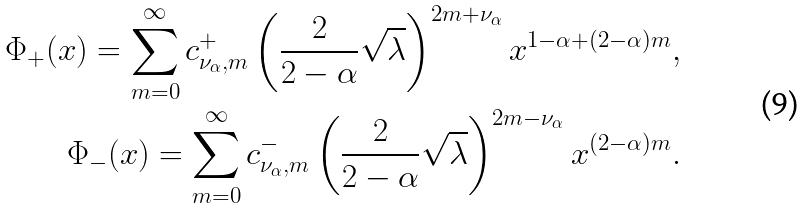Convert formula to latex. <formula><loc_0><loc_0><loc_500><loc_500>\Phi _ { + } ( x ) = \sum _ { m = 0 } ^ { \infty } c _ { \nu _ { \alpha } , m } ^ { + } \left ( \frac { 2 } { 2 - \alpha } \sqrt { \lambda } \right ) ^ { 2 m + \nu _ { \alpha } } x ^ { 1 - \alpha + ( 2 - \alpha ) m } , \\ \Phi _ { - } ( x ) = \sum _ { m = 0 } ^ { \infty } c _ { \nu _ { \alpha } , m } ^ { - } \left ( \frac { 2 } { 2 - \alpha } \sqrt { \lambda } \right ) ^ { 2 m - \nu _ { \alpha } } x ^ { ( 2 - \alpha ) m } .</formula> 